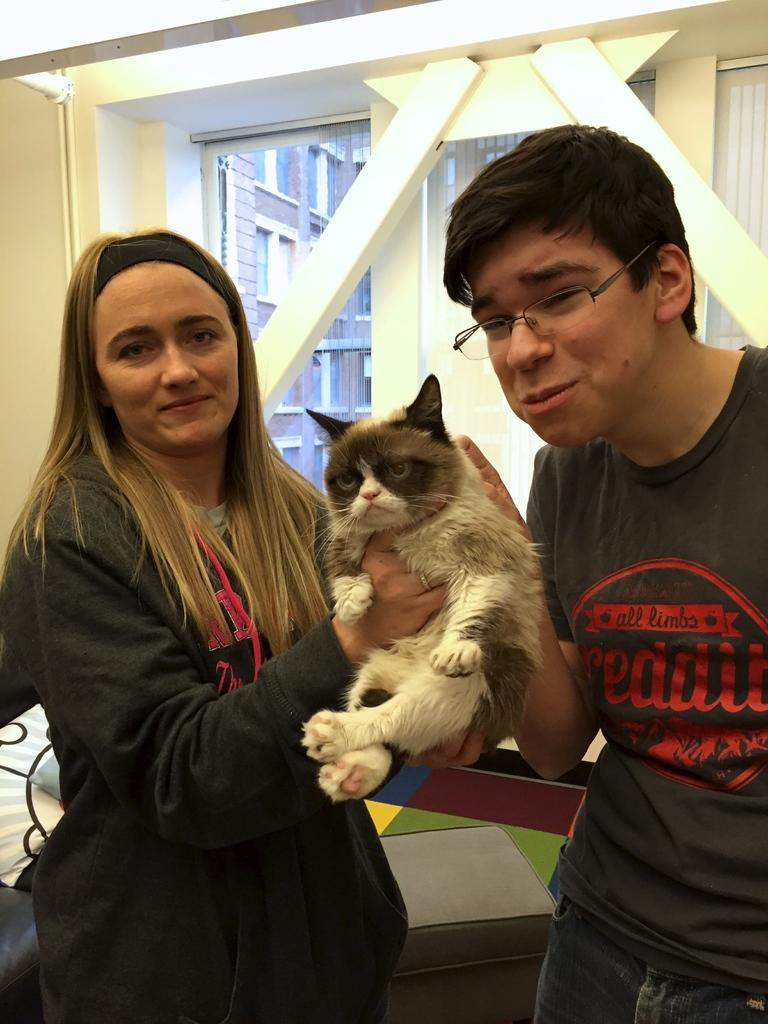How many people are present in the image? There is a woman and a man present in the image. What are the man and woman holding in the image? The man and woman are holding a cat in the image. What can be seen in the background of the image? There is a window, a wall, lights, additional windows, and buildings visible in the background of the image. What type of frame is the cat wearing in the image? There is no frame present in the image, and the cat is not wearing any frame. How does the brain of the cat appear in the image? There is no visible brain of the cat in the image; only the cat's body and face are visible. 